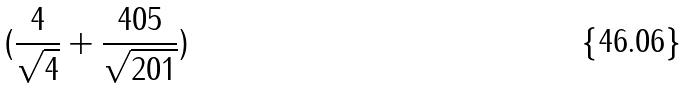<formula> <loc_0><loc_0><loc_500><loc_500>( \frac { 4 } { \sqrt { 4 } } + \frac { 4 0 5 } { \sqrt { 2 0 1 } } )</formula> 